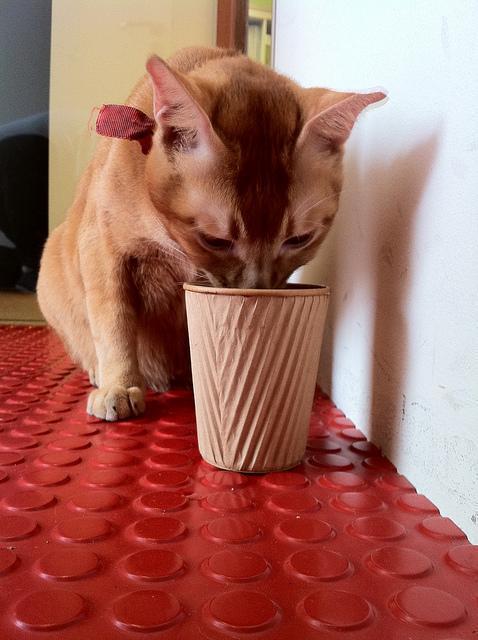How many black horse ?
Give a very brief answer. 0. 